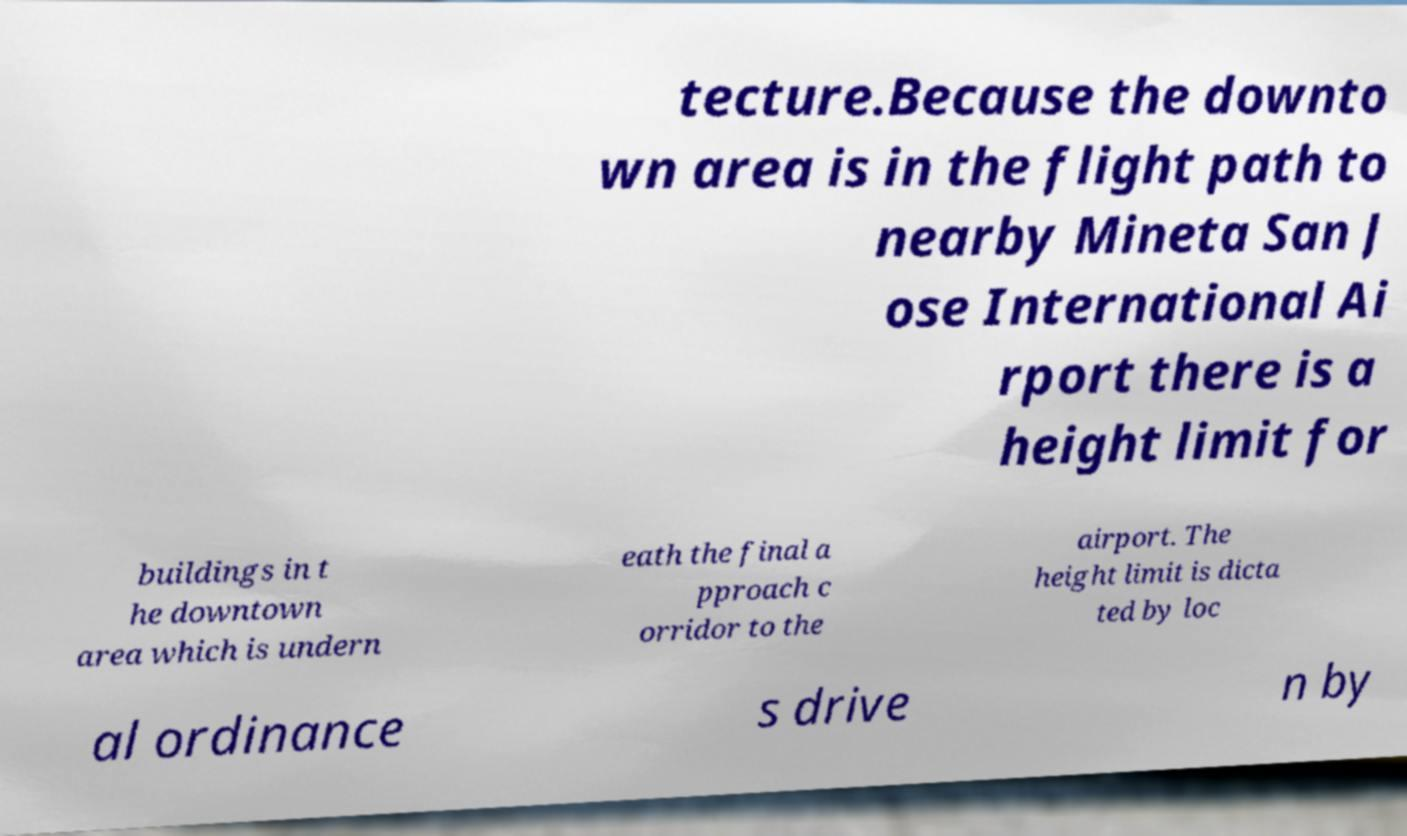There's text embedded in this image that I need extracted. Can you transcribe it verbatim? tecture.Because the downto wn area is in the flight path to nearby Mineta San J ose International Ai rport there is a height limit for buildings in t he downtown area which is undern eath the final a pproach c orridor to the airport. The height limit is dicta ted by loc al ordinance s drive n by 